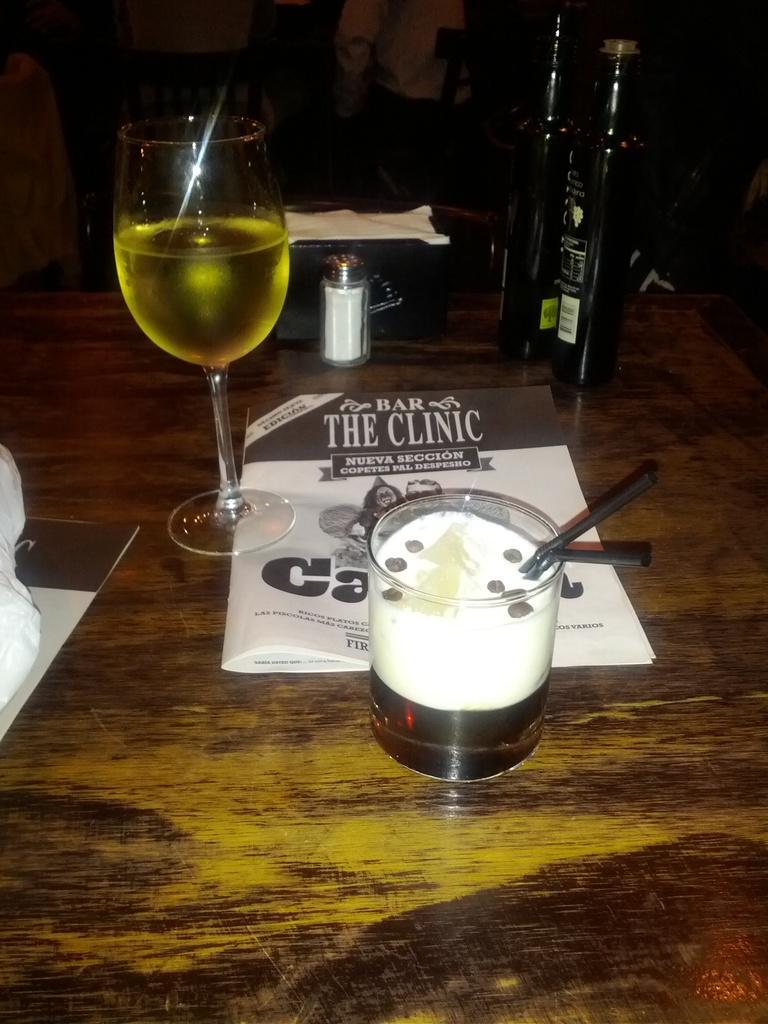Please provide a concise description of this image. This is a table. A wine glass with wine,salt bottle,book,a small glass with some food item inside it. I think this is a straw which is black in color,these are the wine bottles placed on the table. 